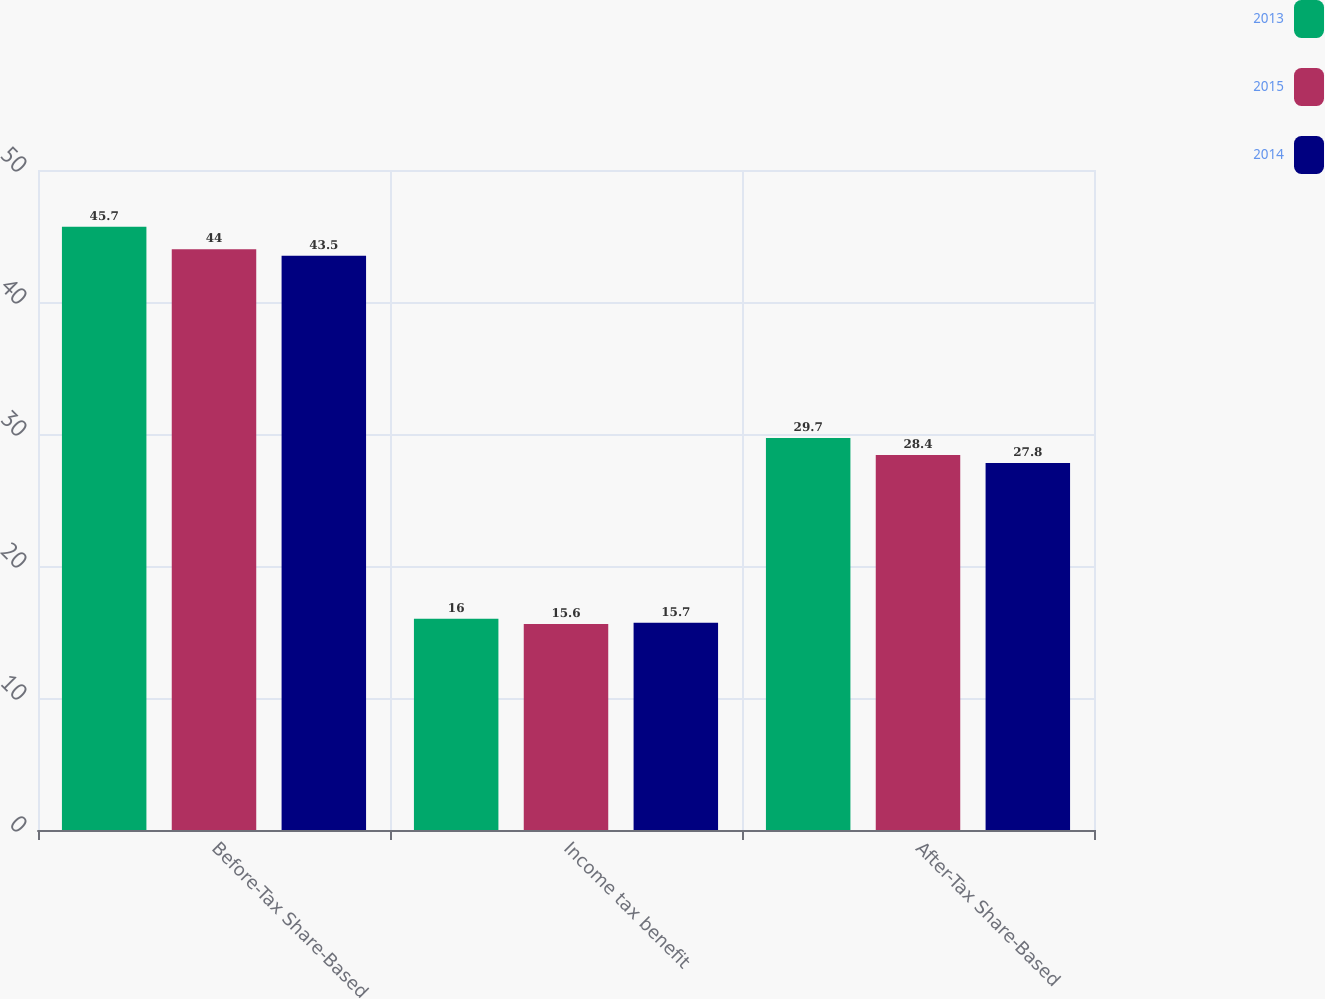<chart> <loc_0><loc_0><loc_500><loc_500><stacked_bar_chart><ecel><fcel>Before-Tax Share-Based<fcel>Income tax benefit<fcel>After-Tax Share-Based<nl><fcel>2013<fcel>45.7<fcel>16<fcel>29.7<nl><fcel>2015<fcel>44<fcel>15.6<fcel>28.4<nl><fcel>2014<fcel>43.5<fcel>15.7<fcel>27.8<nl></chart> 